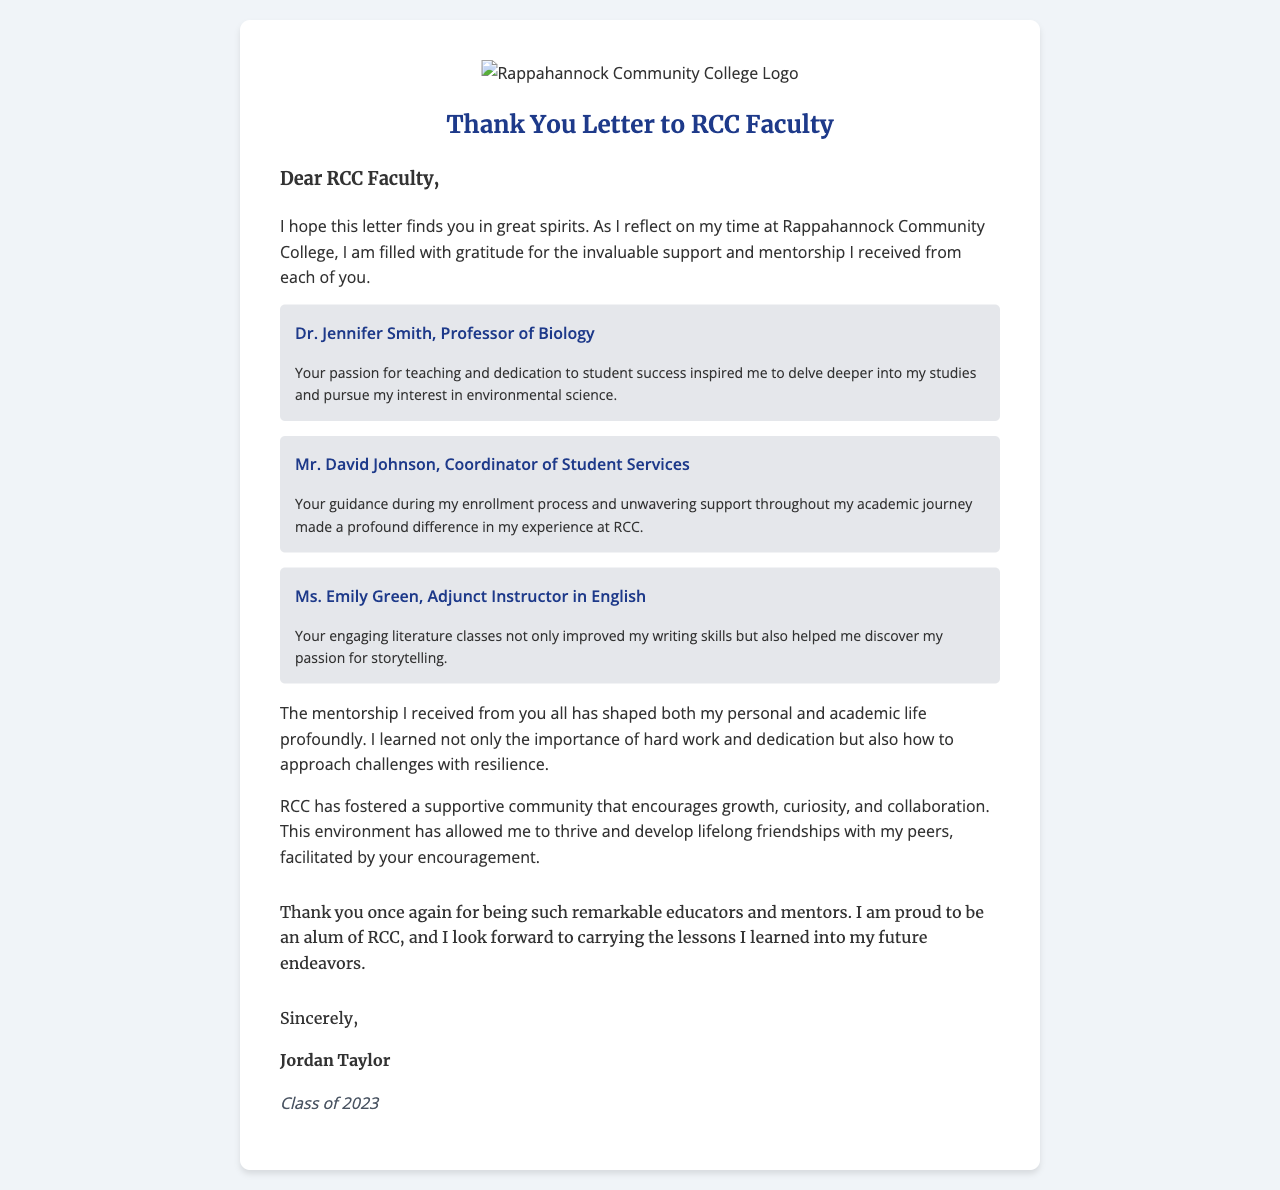What is the name of the sender? The sender's name is given at the end of the letter.
Answer: Jordan Taylor What year did the sender graduate? The graduation year is stated at the bottom of the letter.
Answer: Class of 2023 Who is the Professor of Biology mentioned in the letter? The letter acknowledges a specific professor for their contribution.
Answer: Dr. Jennifer Smith What is the main purpose of this letter? The letter explicitly states its purpose in the opening paragraph.
Answer: Thank you Which subject does Ms. Emily Green teach? The letter mentions the subject area linked to Ms. Green's role.
Answer: English How did the sender feel about the community at RCC? The sender expresses their feelings about the community in a specific paragraph.
Answer: Supportive What role does Mr. David Johnson hold at RCC? The letter describes Mr. Johnson’s position within the college.
Answer: Coordinator of Student Services How is the document visually presented? The letter includes specific formatting elements that enhance its visual appeal.
Answer: HTML document What sentiment does the sender express towards the faculty? The letter highlights the sender's feelings about the faculty in multiple sections.
Answer: Gratitude 